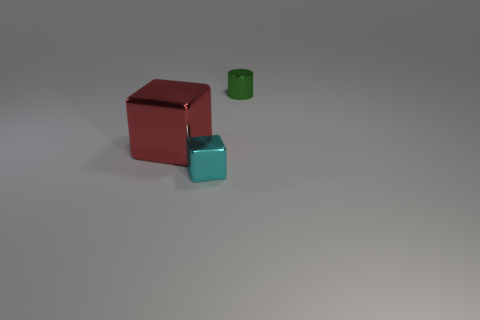What is the material of the big red block?
Offer a very short reply. Metal. There is a thing on the right side of the tiny cyan metallic thing; what is its size?
Provide a succinct answer. Small. How many other tiny cyan objects are the same shape as the small cyan thing?
Your response must be concise. 0. The green thing that is made of the same material as the small cyan thing is what shape?
Your response must be concise. Cylinder. What number of green objects are tiny cylinders or large metallic cubes?
Keep it short and to the point. 1. There is a small green shiny cylinder; are there any small green objects behind it?
Offer a very short reply. No. Does the thing in front of the red thing have the same shape as the small thing behind the large red metallic block?
Your answer should be very brief. No. There is a large thing that is the same shape as the small cyan metallic object; what is it made of?
Offer a very short reply. Metal. What number of cubes are cyan rubber things or small cyan objects?
Keep it short and to the point. 1. What number of big red blocks are the same material as the green cylinder?
Provide a succinct answer. 1. 